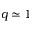<formula> <loc_0><loc_0><loc_500><loc_500>q \simeq 1</formula> 